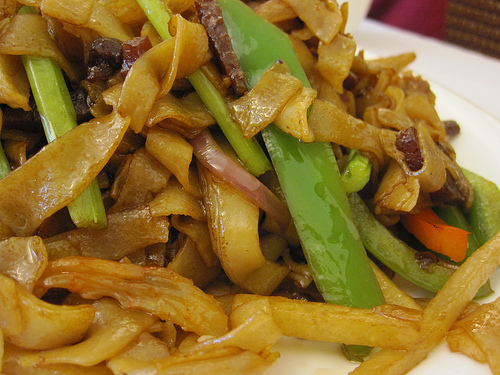<image>
Is there a noodle on the plate? Yes. Looking at the image, I can see the noodle is positioned on top of the plate, with the plate providing support. 